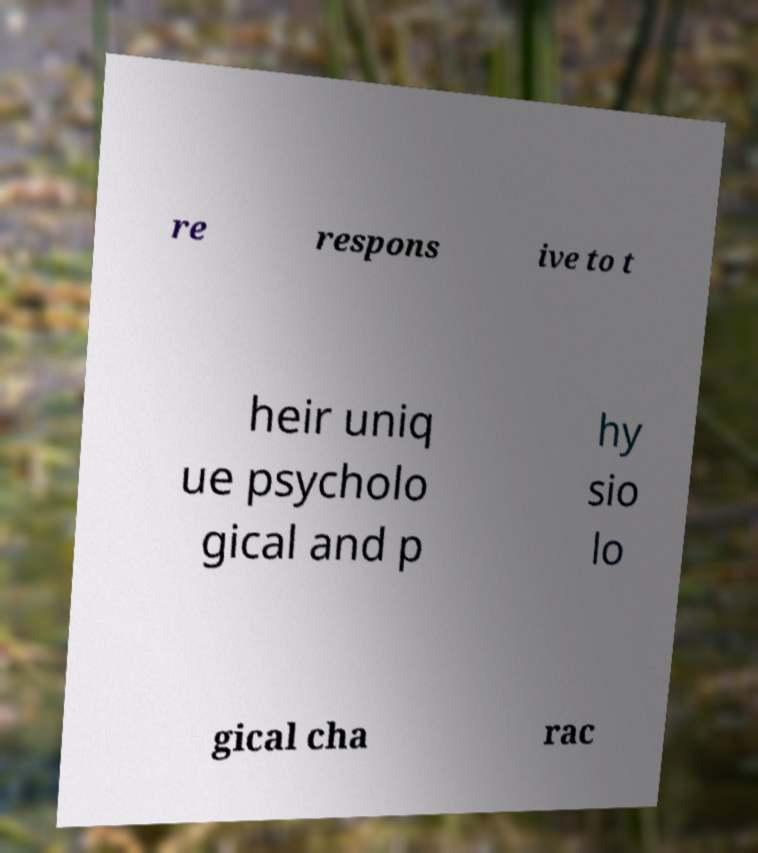What messages or text are displayed in this image? I need them in a readable, typed format. re respons ive to t heir uniq ue psycholo gical and p hy sio lo gical cha rac 